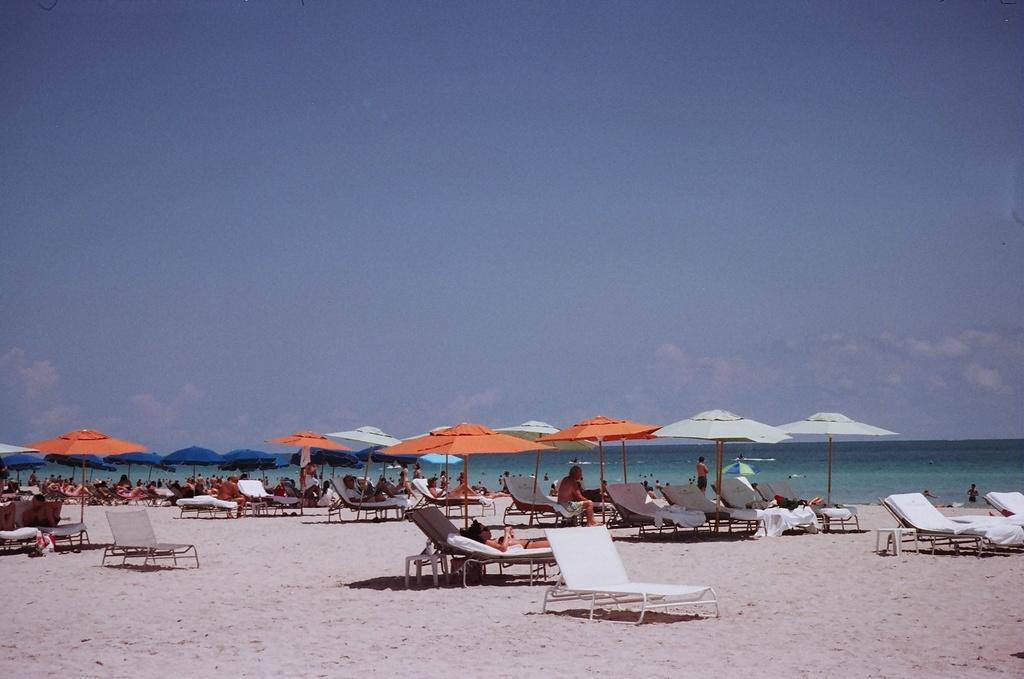What can be seen in the image? There are groups of people, beach umbrellas, sand, chairs, the sea, and the sky visible in the image. What type of setting is depicted in the image? The image shows a beach setting. What might the people in the image be doing? The people in the image might be relaxing, sunbathing, or socializing. What is the weather like in the image? The presence of beach umbrellas and people suggests that it is sunny, and the visibility of the sea and sky indicates a clear day. Can you tell me how many pets are present in the image? There are no pets visible in the image. What type of drink is being served to the people in the image? There is no drink present in the image; it shows people at a beach setting with beach umbrellas, sand, chairs, the sea, and the sky. 